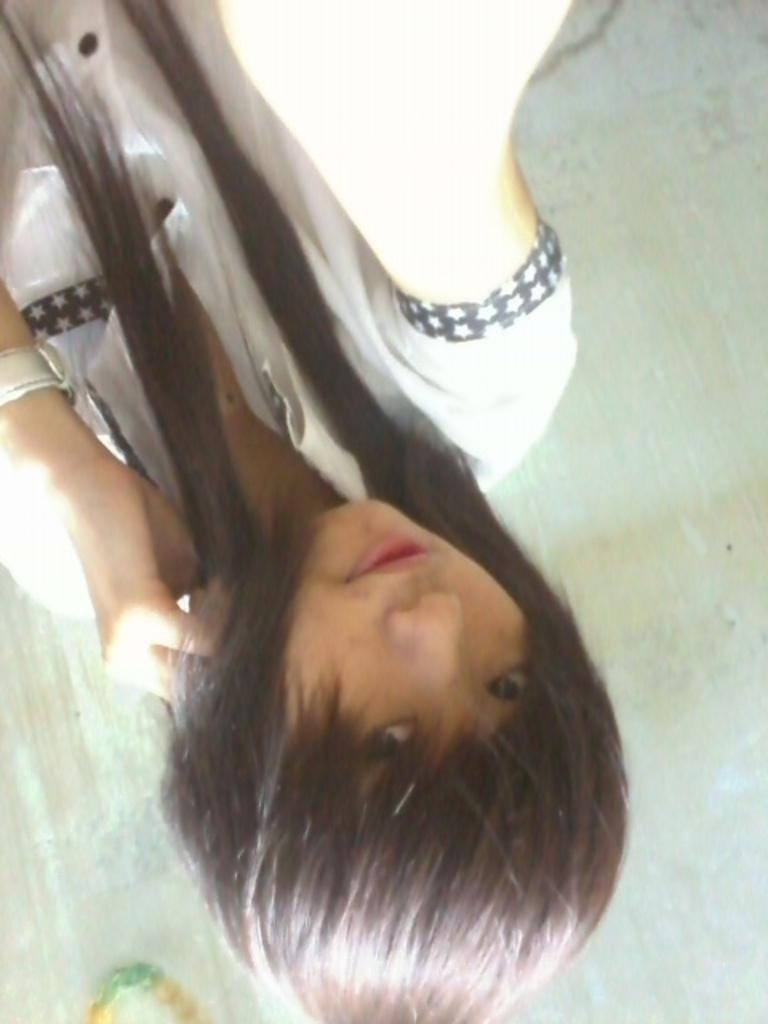Can you describe this image briefly? In the image there is a girl in inverted position, she wore white dress and had long hair. 